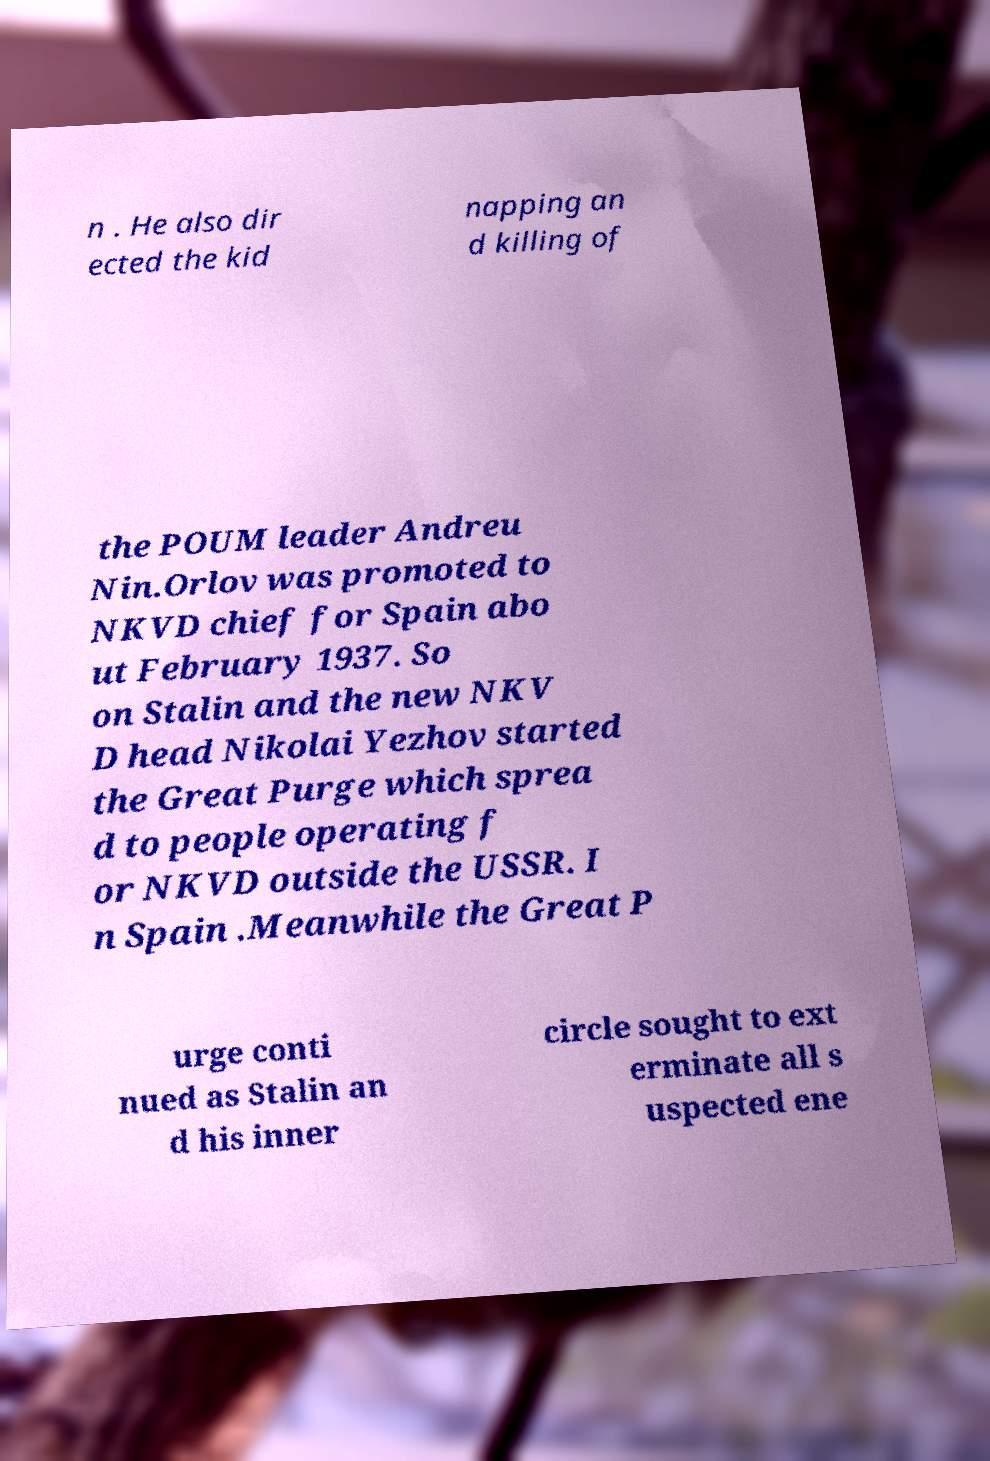Could you assist in decoding the text presented in this image and type it out clearly? n . He also dir ected the kid napping an d killing of the POUM leader Andreu Nin.Orlov was promoted to NKVD chief for Spain abo ut February 1937. So on Stalin and the new NKV D head Nikolai Yezhov started the Great Purge which sprea d to people operating f or NKVD outside the USSR. I n Spain .Meanwhile the Great P urge conti nued as Stalin an d his inner circle sought to ext erminate all s uspected ene 